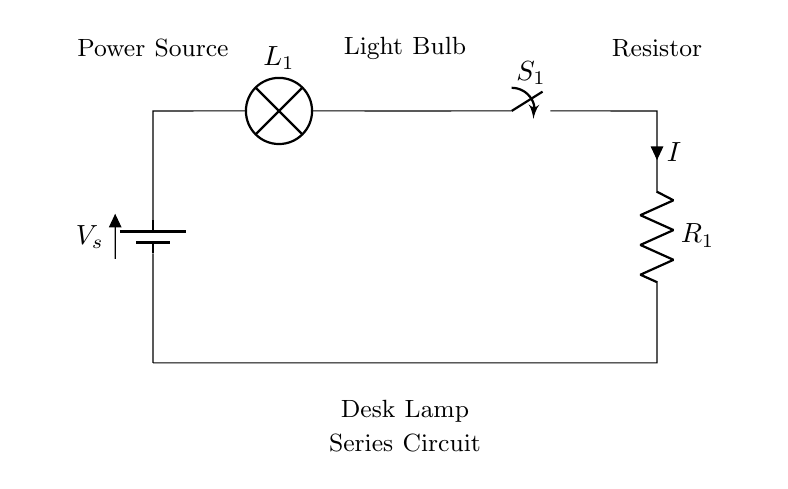What is the power source in this circuit? The power source is indicated by the battery symbol labeled as V_s, which provides energy to the circuit.
Answer: V_s How many components are in the circuit? The circuit contains four components: one battery, one lamp, one switch, and one resistor.
Answer: Four What is the function of the switch? The switch, labeled S_1, controls the flow of current in the circuit, allowing it to be turned on or off.
Answer: Control current What is the relationship between current and resistance in this circuit? According to Ohm's Law, current (I) is inversely proportional to resistance (R) when voltage (V) is constant. Here, a higher resistance would result in lower current.
Answer: Inversely proportional If the lamp is lit, what can be inferred about the switch? If the lamp is lit, it means the switch (S_1) must be closed, allowing current to flow through the circuit.
Answer: Closed What happens to the light bulb if the resistor value is increased? Increasing the resistor value reduces the current flowing through the circuit, which in turn reduces the brightness of the light bulb.
Answer: Dimmer light What type of circuit is depicted here? The circuit shown is a series circuit, where the components are connected end-to-end in a single path for the current.
Answer: Series circuit 